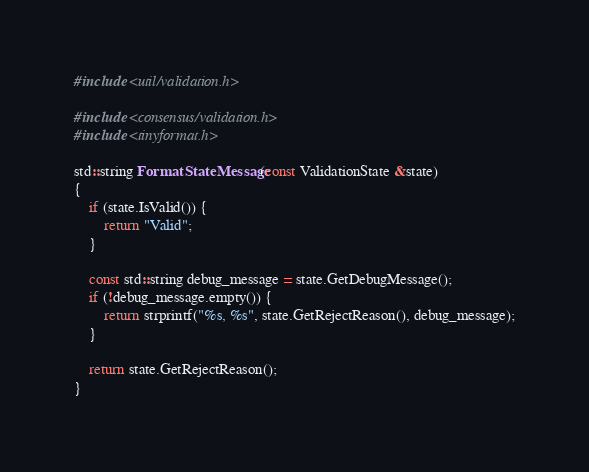Convert code to text. <code><loc_0><loc_0><loc_500><loc_500><_C++_>#include <util/validation.h>

#include <consensus/validation.h>
#include <tinyformat.h>

std::string FormatStateMessage(const ValidationState &state)
{
    if (state.IsValid()) {
        return "Valid";
    }

    const std::string debug_message = state.GetDebugMessage();
    if (!debug_message.empty()) {
        return strprintf("%s, %s", state.GetRejectReason(), debug_message);
    }

    return state.GetRejectReason();
}
</code> 